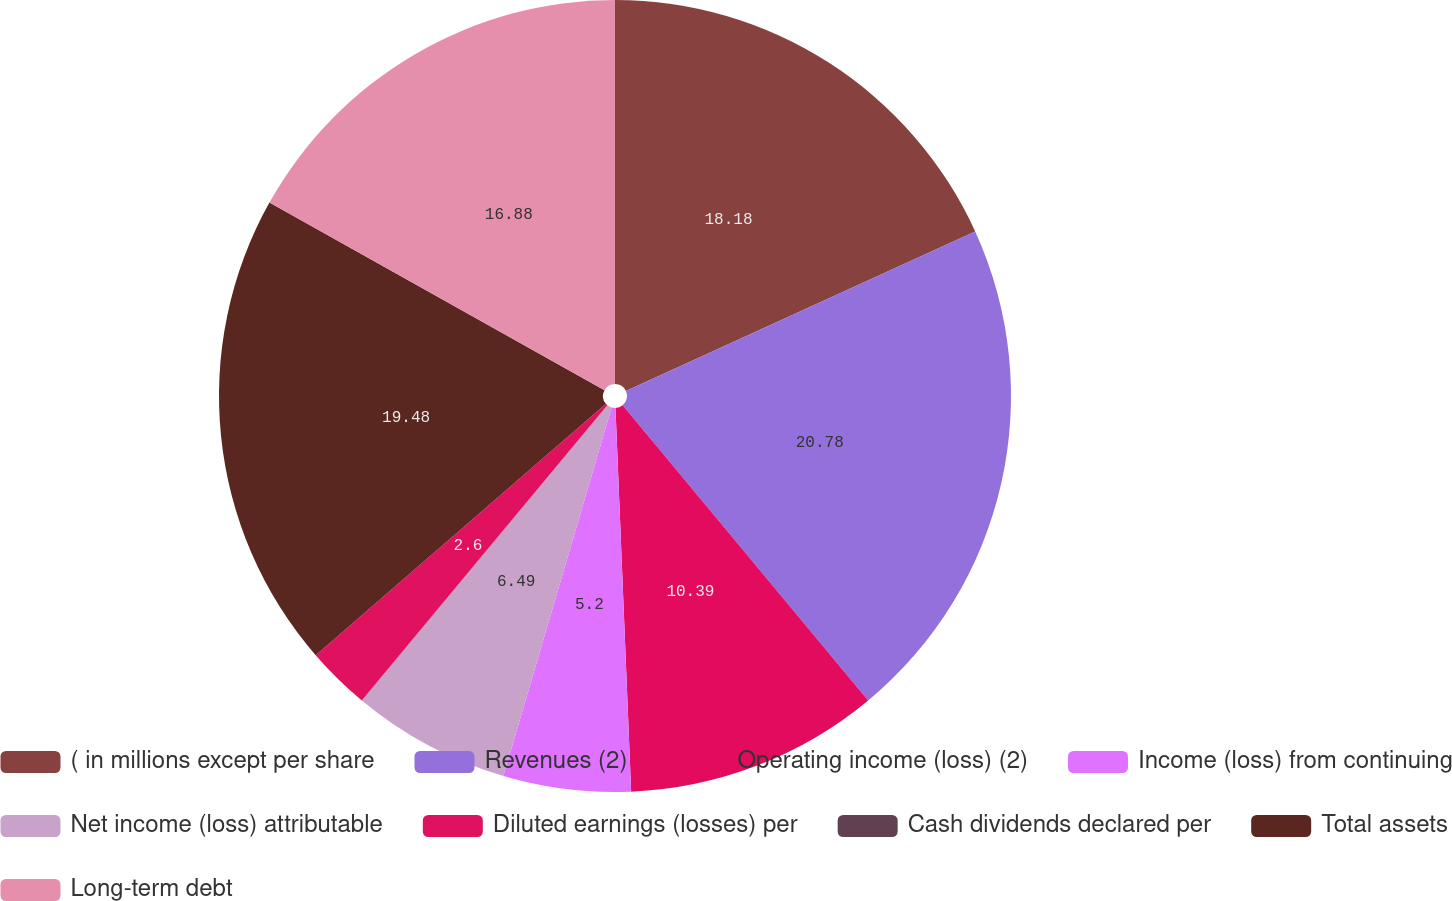Convert chart to OTSL. <chart><loc_0><loc_0><loc_500><loc_500><pie_chart><fcel>( in millions except per share<fcel>Revenues (2)<fcel>Operating income (loss) (2)<fcel>Income (loss) from continuing<fcel>Net income (loss) attributable<fcel>Diluted earnings (losses) per<fcel>Cash dividends declared per<fcel>Total assets<fcel>Long-term debt<nl><fcel>18.18%<fcel>20.78%<fcel>10.39%<fcel>5.2%<fcel>6.49%<fcel>2.6%<fcel>0.0%<fcel>19.48%<fcel>16.88%<nl></chart> 